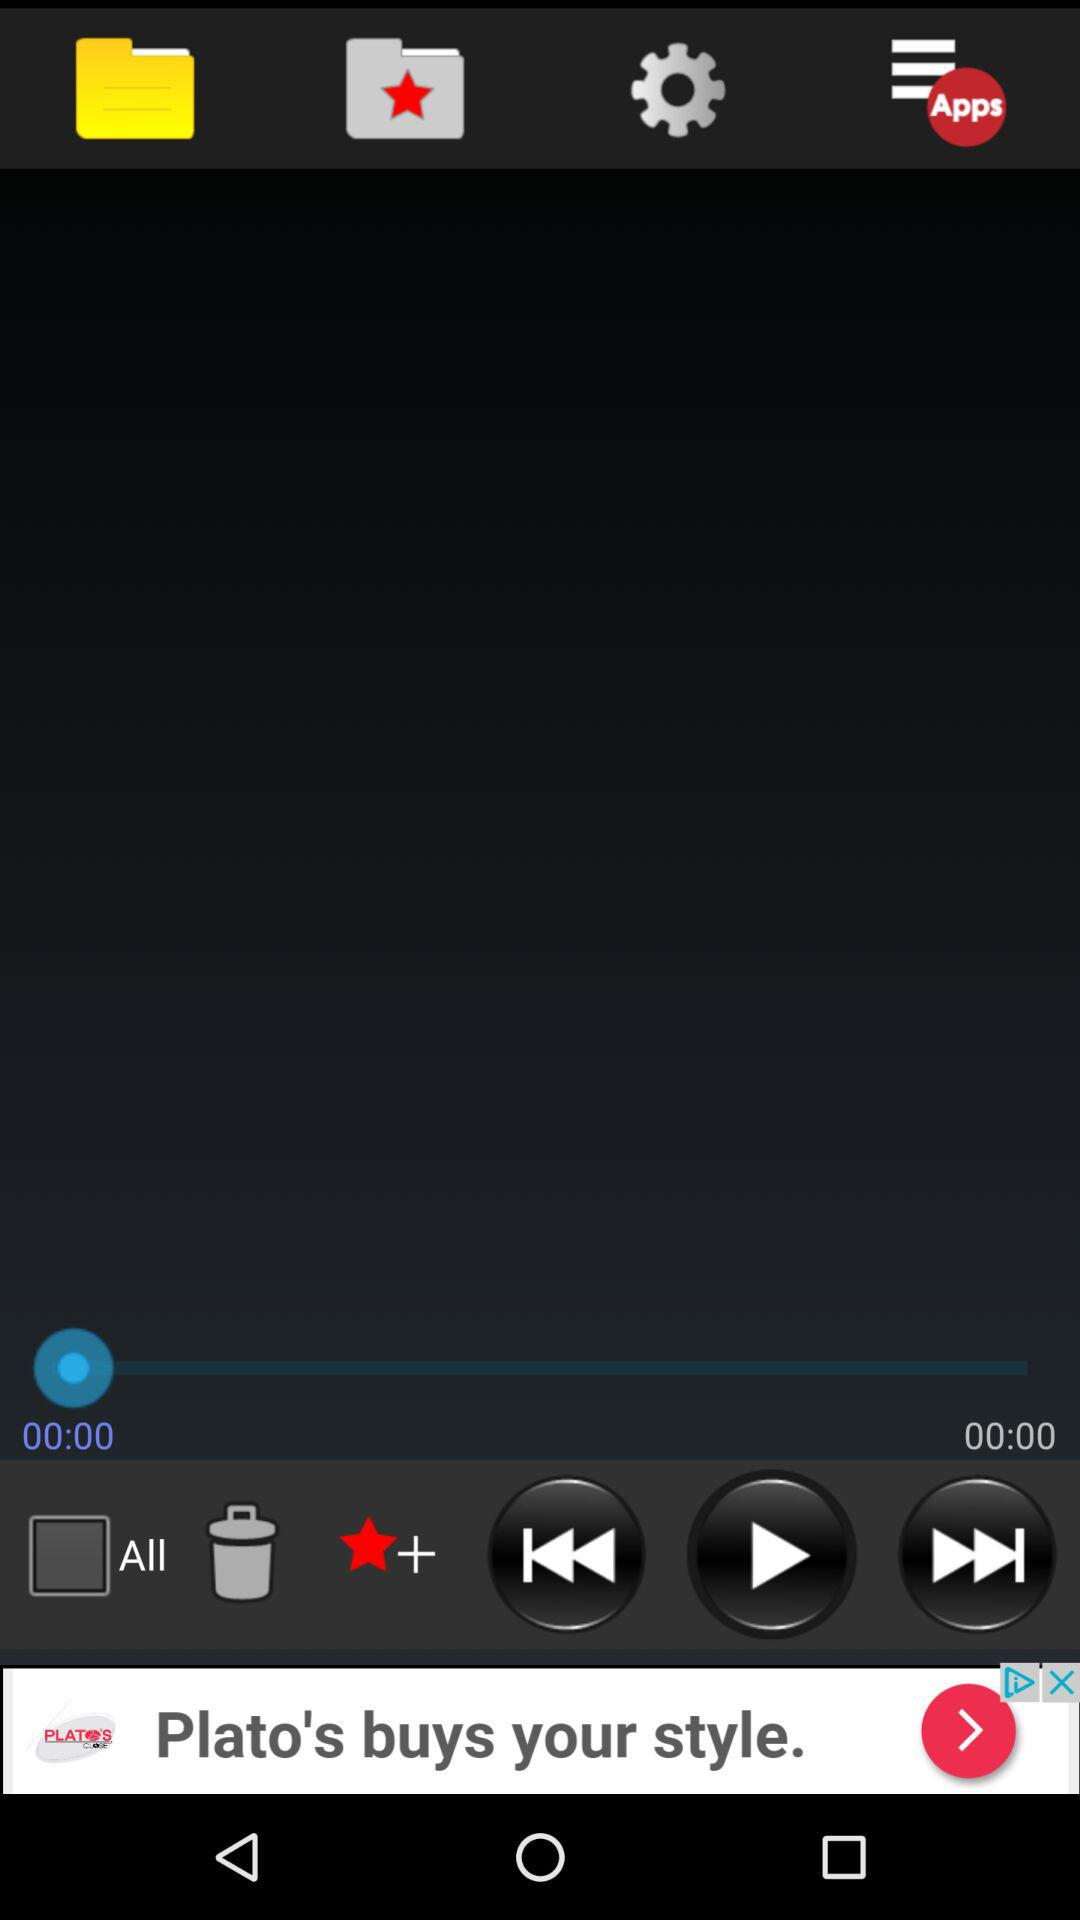What is the status of "All"? The status is "off". 